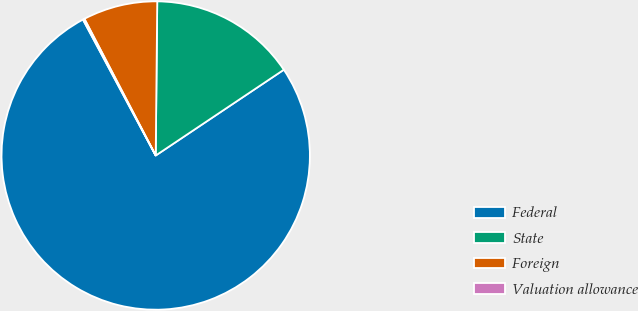<chart> <loc_0><loc_0><loc_500><loc_500><pie_chart><fcel>Federal<fcel>State<fcel>Foreign<fcel>Valuation allowance<nl><fcel>76.57%<fcel>15.45%<fcel>7.81%<fcel>0.17%<nl></chart> 